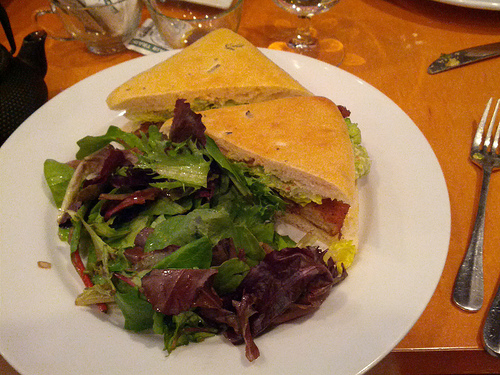Is the fork on the right side? Absolutely, the fork is situated on the right side of the plate as viewed in the image. 